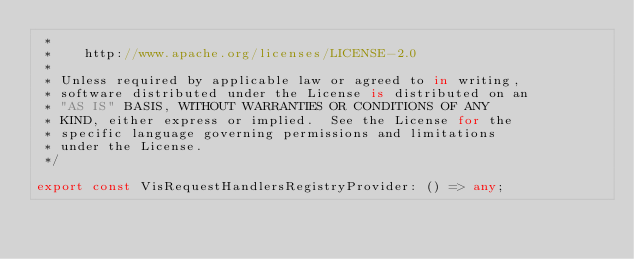Convert code to text. <code><loc_0><loc_0><loc_500><loc_500><_TypeScript_> *
 *    http://www.apache.org/licenses/LICENSE-2.0
 *
 * Unless required by applicable law or agreed to in writing,
 * software distributed under the License is distributed on an
 * "AS IS" BASIS, WITHOUT WARRANTIES OR CONDITIONS OF ANY
 * KIND, either express or implied.  See the License for the
 * specific language governing permissions and limitations
 * under the License.
 */

export const VisRequestHandlersRegistryProvider: () => any;
</code> 